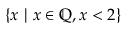<formula> <loc_0><loc_0><loc_500><loc_500>\{ x \ | \ x \in \mathbb { Q } , x < 2 \}</formula> 